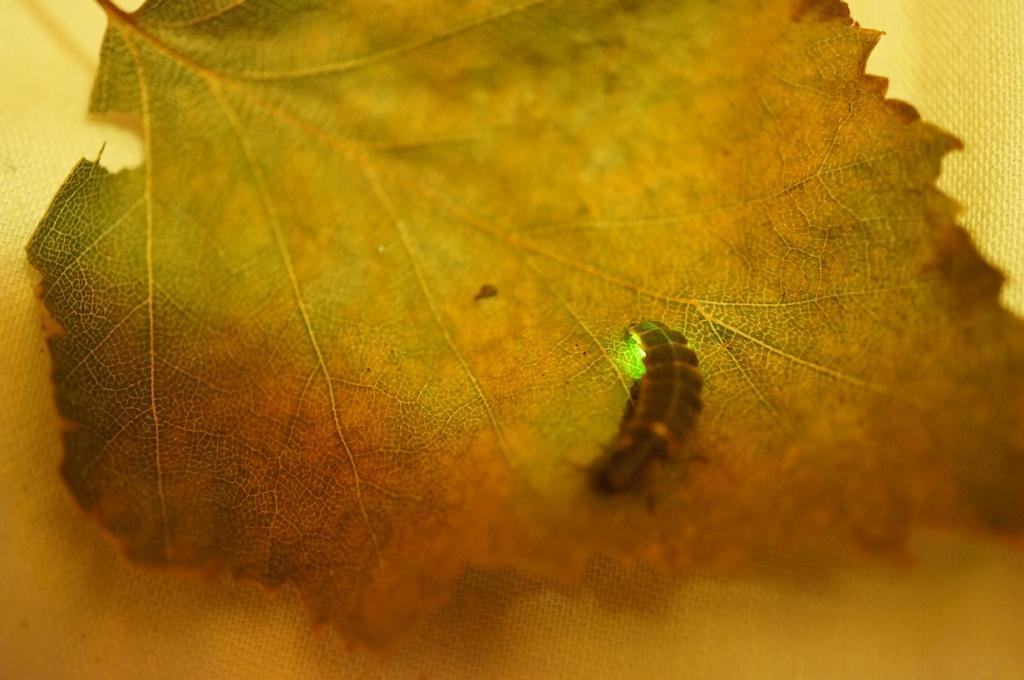Please provide a concise description of this image. In this image I can see an insect on the green and brown color leaf. Background is in yellow color. 